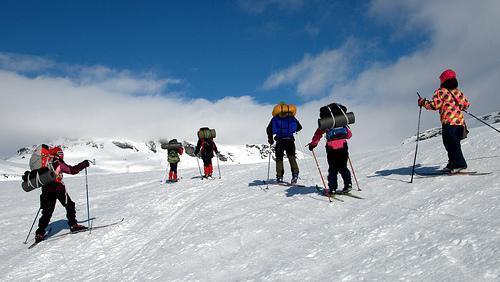How many people are there?
Give a very brief answer. 6. 